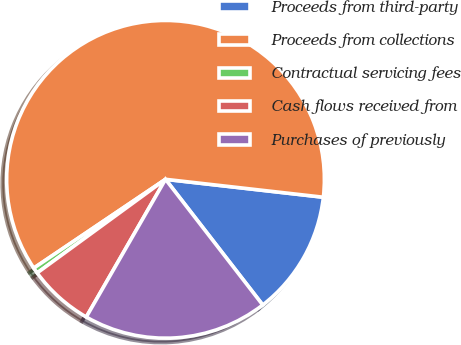Convert chart to OTSL. <chart><loc_0><loc_0><loc_500><loc_500><pie_chart><fcel>Proceeds from third-party<fcel>Proceeds from collections<fcel>Contractual servicing fees<fcel>Cash flows received from<fcel>Purchases of previously<nl><fcel>12.72%<fcel>61.24%<fcel>0.59%<fcel>6.66%<fcel>18.79%<nl></chart> 